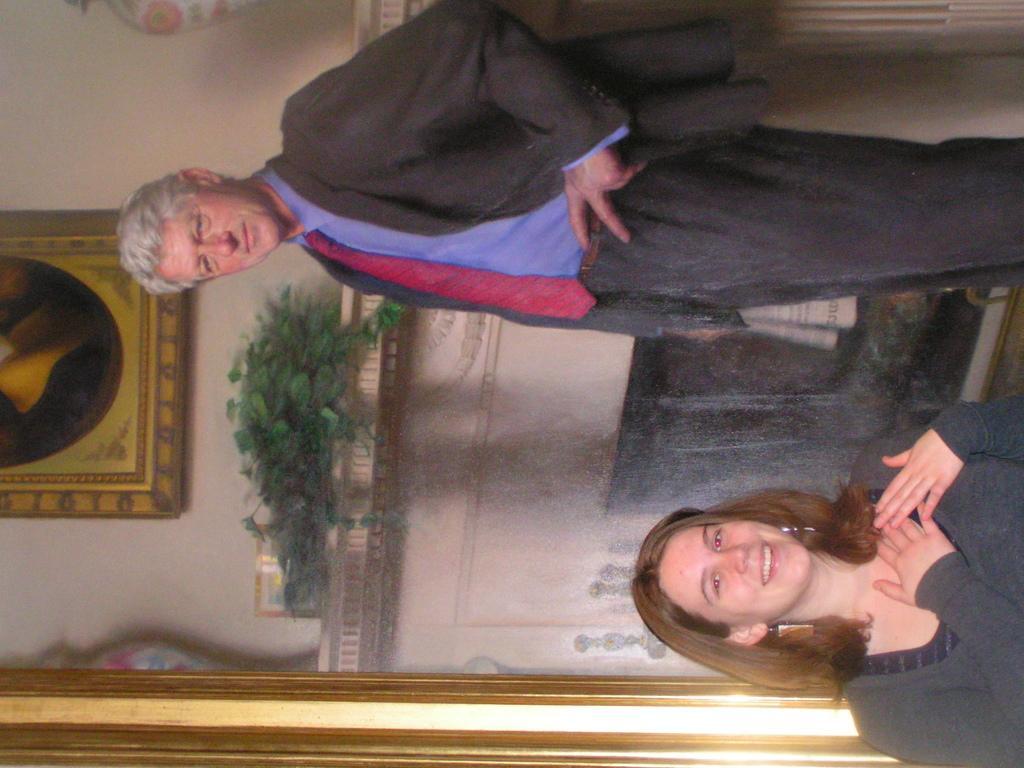Could you give a brief overview of what you see in this image? In this rotated image there is a girl standing. Behind her there is a picture frame. In the picture frame there is a man standing. Behind the man there is a wall. At the bottom there is a fireplace to the wall. There are picture frames hanging on the wall. On the fire place there are house plants and vases. 